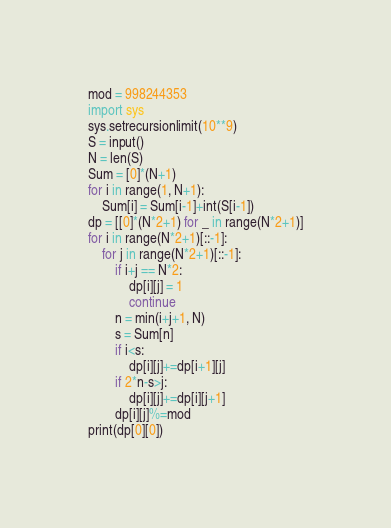<code> <loc_0><loc_0><loc_500><loc_500><_Python_>mod = 998244353
import sys
sys.setrecursionlimit(10**9)
S = input()
N = len(S)
Sum = [0]*(N+1)
for i in range(1, N+1):
    Sum[i] = Sum[i-1]+int(S[i-1])
dp = [[0]*(N*2+1) for _ in range(N*2+1)]
for i in range(N*2+1)[::-1]:
    for j in range(N*2+1)[::-1]:
        if i+j == N*2:
            dp[i][j] = 1
            continue
        n = min(i+j+1, N)
        s = Sum[n]
        if i<s:
            dp[i][j]+=dp[i+1][j]
        if 2*n-s>j:
            dp[i][j]+=dp[i][j+1]
        dp[i][j]%=mod
print(dp[0][0])   </code> 